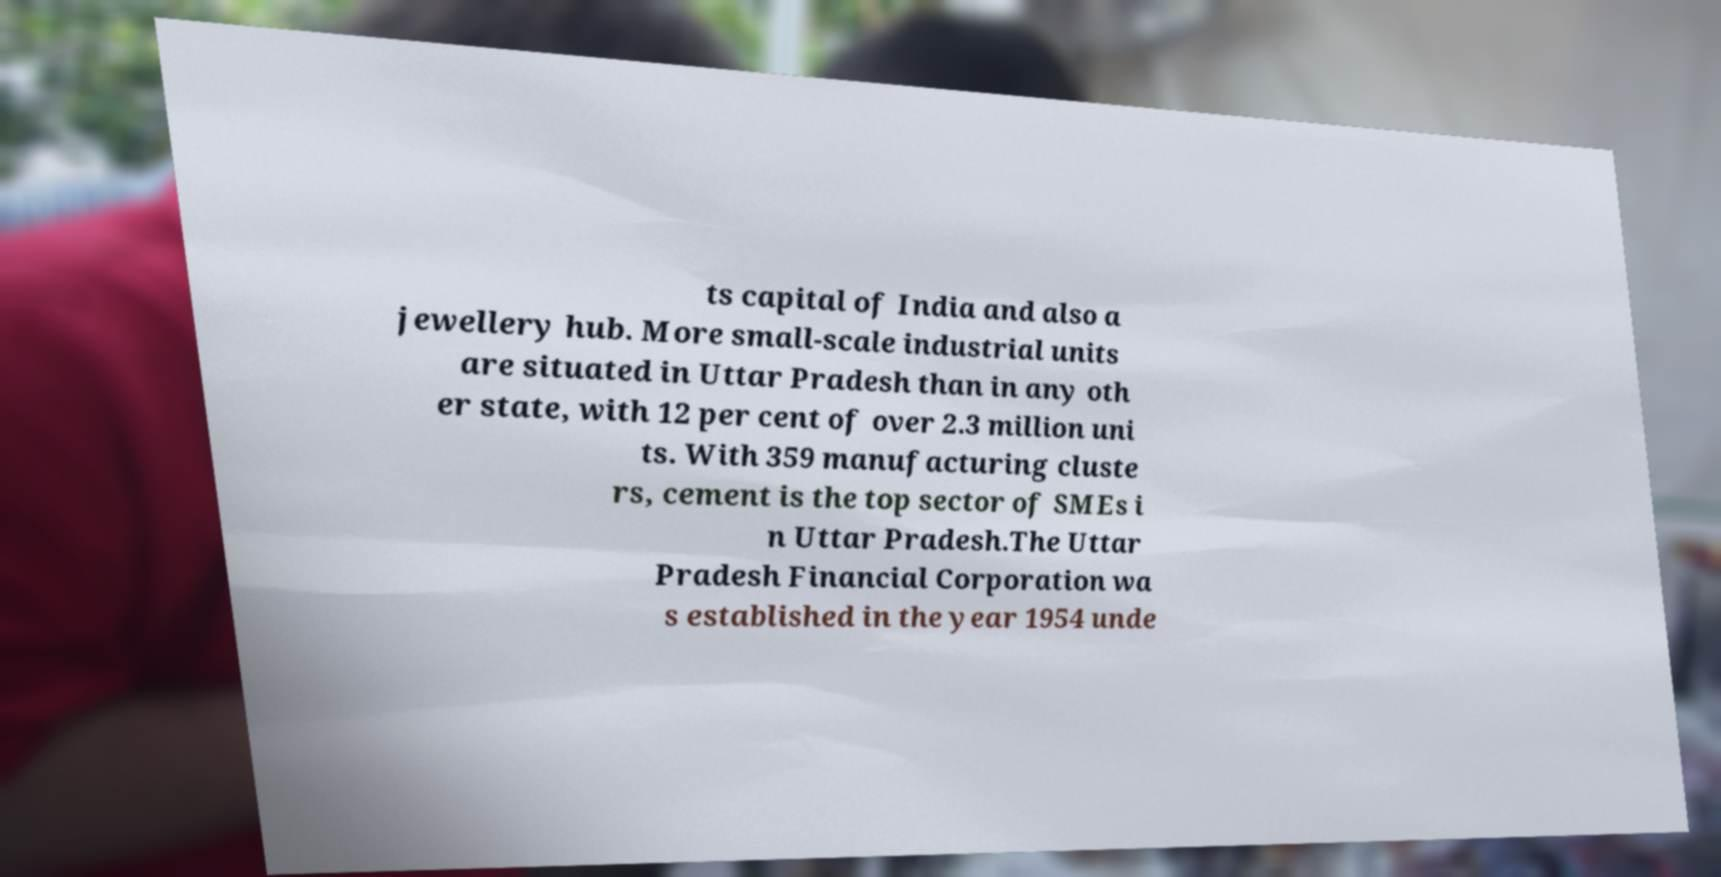There's text embedded in this image that I need extracted. Can you transcribe it verbatim? ts capital of India and also a jewellery hub. More small-scale industrial units are situated in Uttar Pradesh than in any oth er state, with 12 per cent of over 2.3 million uni ts. With 359 manufacturing cluste rs, cement is the top sector of SMEs i n Uttar Pradesh.The Uttar Pradesh Financial Corporation wa s established in the year 1954 unde 